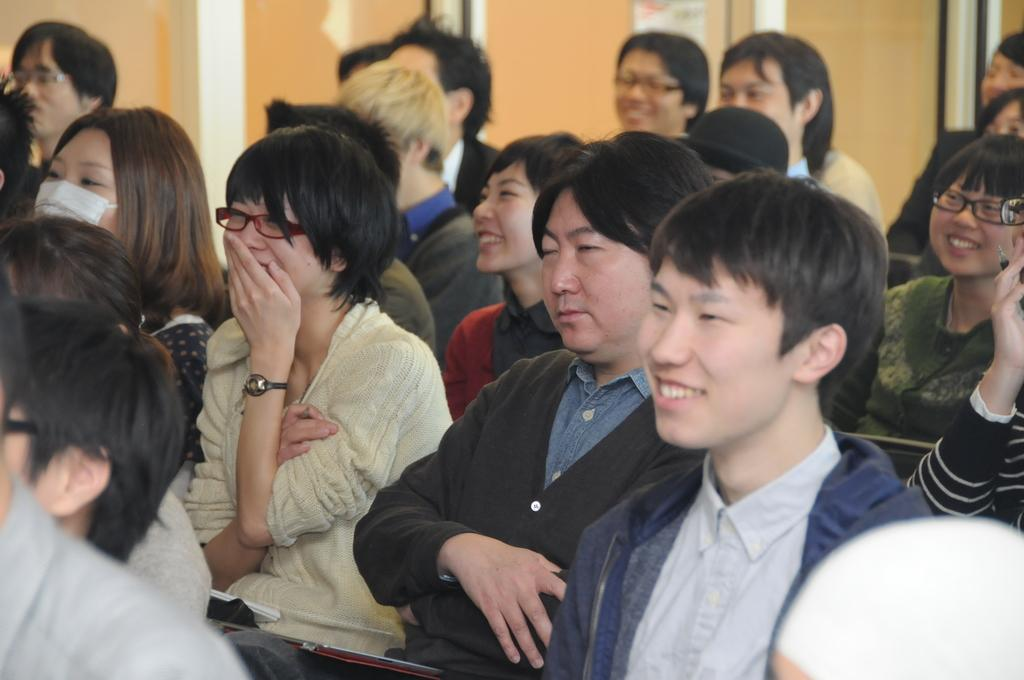What are the people in the image doing? The people in the center of the image are sitting in chairs, and many of them are laughing. What can be seen in the background of the image? There are pillars and a wall in the background of the image. What grade does the detail on the wall represent in the image? There is no grade mentioned or visible on the wall in the image. 